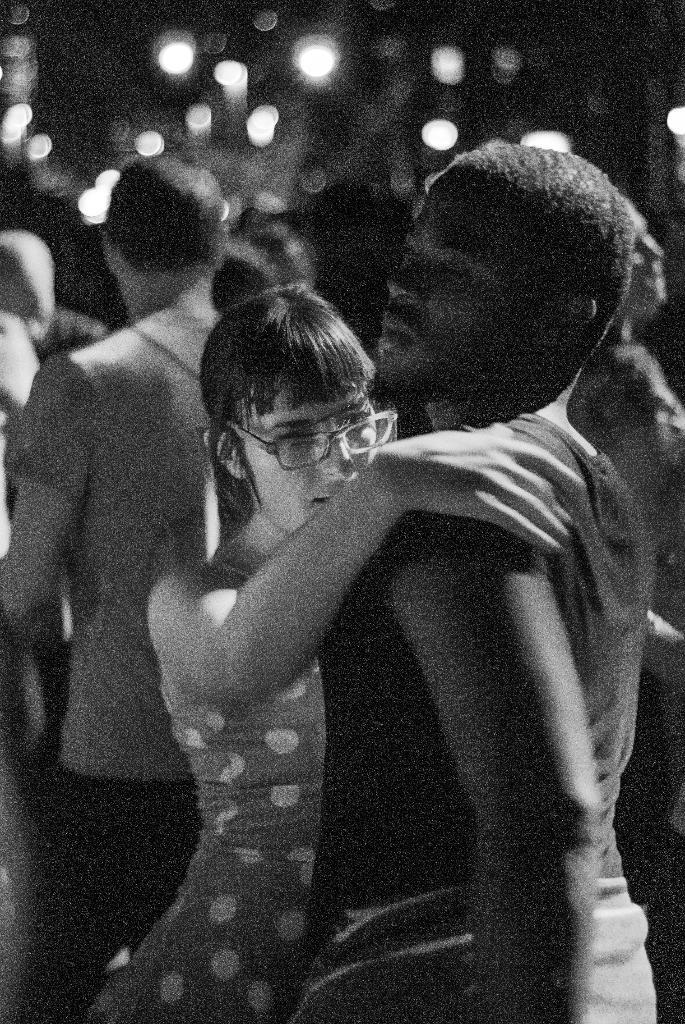What is the color scheme of the image? The image is black and white. What are the people in the image doing? People are dancing in the image. How many wings can be seen on the people dancing in the image? There are no wings visible on the people dancing in the image, as it is a black and white photograph. What country are the people dancing in? The provided facts do not mention the country where the people are dancing. 